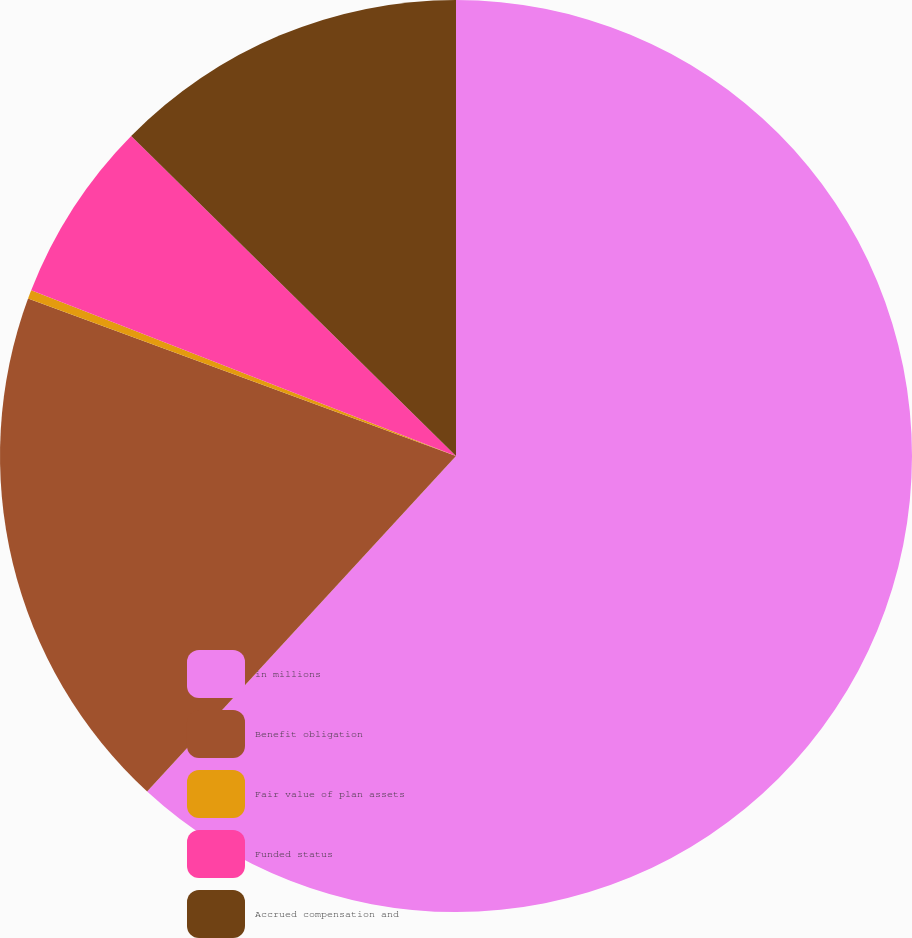<chart> <loc_0><loc_0><loc_500><loc_500><pie_chart><fcel>in millions<fcel>Benefit obligation<fcel>Fair value of plan assets<fcel>Funded status<fcel>Accrued compensation and<nl><fcel>61.85%<fcel>18.77%<fcel>0.31%<fcel>6.46%<fcel>12.62%<nl></chart> 